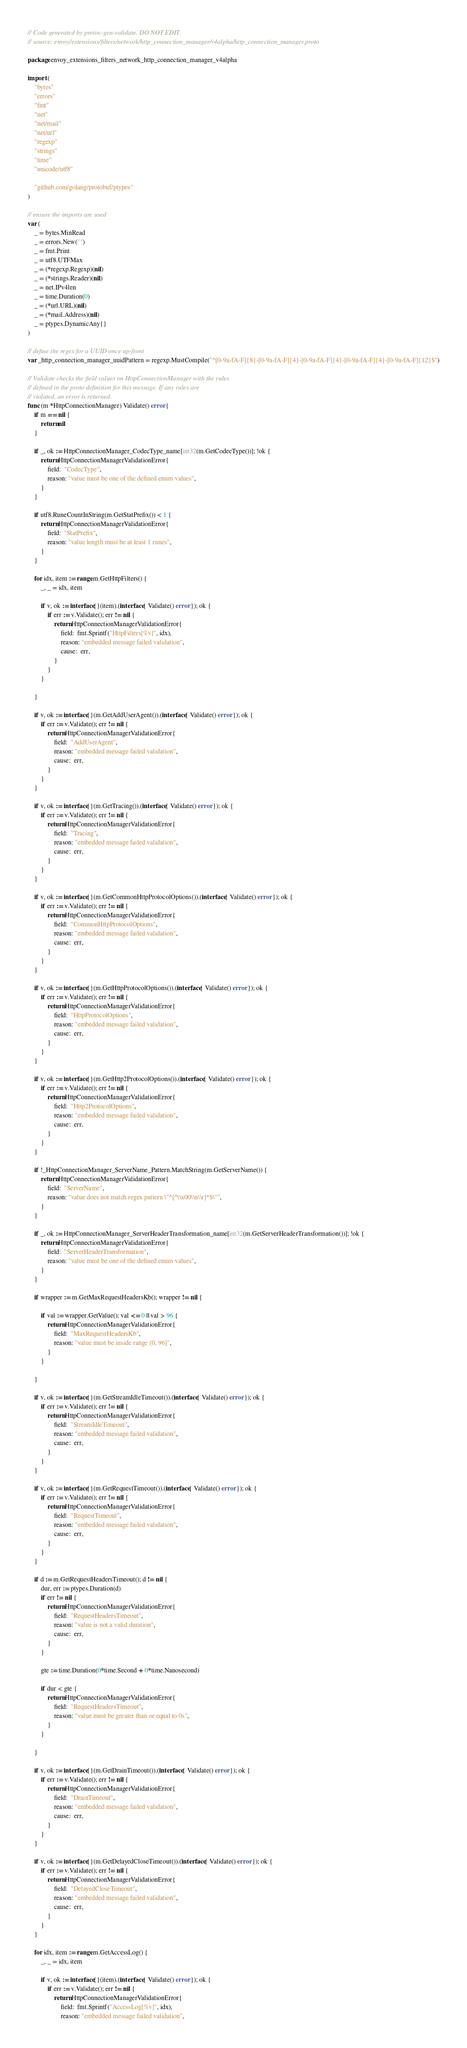<code> <loc_0><loc_0><loc_500><loc_500><_Go_>// Code generated by protoc-gen-validate. DO NOT EDIT.
// source: envoy/extensions/filters/network/http_connection_manager/v4alpha/http_connection_manager.proto

package envoy_extensions_filters_network_http_connection_manager_v4alpha

import (
	"bytes"
	"errors"
	"fmt"
	"net"
	"net/mail"
	"net/url"
	"regexp"
	"strings"
	"time"
	"unicode/utf8"

	"github.com/golang/protobuf/ptypes"
)

// ensure the imports are used
var (
	_ = bytes.MinRead
	_ = errors.New("")
	_ = fmt.Print
	_ = utf8.UTFMax
	_ = (*regexp.Regexp)(nil)
	_ = (*strings.Reader)(nil)
	_ = net.IPv4len
	_ = time.Duration(0)
	_ = (*url.URL)(nil)
	_ = (*mail.Address)(nil)
	_ = ptypes.DynamicAny{}
)

// define the regex for a UUID once up-front
var _http_connection_manager_uuidPattern = regexp.MustCompile("^[0-9a-fA-F]{8}-[0-9a-fA-F]{4}-[0-9a-fA-F]{4}-[0-9a-fA-F]{4}-[0-9a-fA-F]{12}$")

// Validate checks the field values on HttpConnectionManager with the rules
// defined in the proto definition for this message. If any rules are
// violated, an error is returned.
func (m *HttpConnectionManager) Validate() error {
	if m == nil {
		return nil
	}

	if _, ok := HttpConnectionManager_CodecType_name[int32(m.GetCodecType())]; !ok {
		return HttpConnectionManagerValidationError{
			field:  "CodecType",
			reason: "value must be one of the defined enum values",
		}
	}

	if utf8.RuneCountInString(m.GetStatPrefix()) < 1 {
		return HttpConnectionManagerValidationError{
			field:  "StatPrefix",
			reason: "value length must be at least 1 runes",
		}
	}

	for idx, item := range m.GetHttpFilters() {
		_, _ = idx, item

		if v, ok := interface{}(item).(interface{ Validate() error }); ok {
			if err := v.Validate(); err != nil {
				return HttpConnectionManagerValidationError{
					field:  fmt.Sprintf("HttpFilters[%v]", idx),
					reason: "embedded message failed validation",
					cause:  err,
				}
			}
		}

	}

	if v, ok := interface{}(m.GetAddUserAgent()).(interface{ Validate() error }); ok {
		if err := v.Validate(); err != nil {
			return HttpConnectionManagerValidationError{
				field:  "AddUserAgent",
				reason: "embedded message failed validation",
				cause:  err,
			}
		}
	}

	if v, ok := interface{}(m.GetTracing()).(interface{ Validate() error }); ok {
		if err := v.Validate(); err != nil {
			return HttpConnectionManagerValidationError{
				field:  "Tracing",
				reason: "embedded message failed validation",
				cause:  err,
			}
		}
	}

	if v, ok := interface{}(m.GetCommonHttpProtocolOptions()).(interface{ Validate() error }); ok {
		if err := v.Validate(); err != nil {
			return HttpConnectionManagerValidationError{
				field:  "CommonHttpProtocolOptions",
				reason: "embedded message failed validation",
				cause:  err,
			}
		}
	}

	if v, ok := interface{}(m.GetHttpProtocolOptions()).(interface{ Validate() error }); ok {
		if err := v.Validate(); err != nil {
			return HttpConnectionManagerValidationError{
				field:  "HttpProtocolOptions",
				reason: "embedded message failed validation",
				cause:  err,
			}
		}
	}

	if v, ok := interface{}(m.GetHttp2ProtocolOptions()).(interface{ Validate() error }); ok {
		if err := v.Validate(); err != nil {
			return HttpConnectionManagerValidationError{
				field:  "Http2ProtocolOptions",
				reason: "embedded message failed validation",
				cause:  err,
			}
		}
	}

	if !_HttpConnectionManager_ServerName_Pattern.MatchString(m.GetServerName()) {
		return HttpConnectionManagerValidationError{
			field:  "ServerName",
			reason: "value does not match regex pattern \"^[^\\x00\\n\\r]*$\"",
		}
	}

	if _, ok := HttpConnectionManager_ServerHeaderTransformation_name[int32(m.GetServerHeaderTransformation())]; !ok {
		return HttpConnectionManagerValidationError{
			field:  "ServerHeaderTransformation",
			reason: "value must be one of the defined enum values",
		}
	}

	if wrapper := m.GetMaxRequestHeadersKb(); wrapper != nil {

		if val := wrapper.GetValue(); val <= 0 || val > 96 {
			return HttpConnectionManagerValidationError{
				field:  "MaxRequestHeadersKb",
				reason: "value must be inside range (0, 96]",
			}
		}

	}

	if v, ok := interface{}(m.GetStreamIdleTimeout()).(interface{ Validate() error }); ok {
		if err := v.Validate(); err != nil {
			return HttpConnectionManagerValidationError{
				field:  "StreamIdleTimeout",
				reason: "embedded message failed validation",
				cause:  err,
			}
		}
	}

	if v, ok := interface{}(m.GetRequestTimeout()).(interface{ Validate() error }); ok {
		if err := v.Validate(); err != nil {
			return HttpConnectionManagerValidationError{
				field:  "RequestTimeout",
				reason: "embedded message failed validation",
				cause:  err,
			}
		}
	}

	if d := m.GetRequestHeadersTimeout(); d != nil {
		dur, err := ptypes.Duration(d)
		if err != nil {
			return HttpConnectionManagerValidationError{
				field:  "RequestHeadersTimeout",
				reason: "value is not a valid duration",
				cause:  err,
			}
		}

		gte := time.Duration(0*time.Second + 0*time.Nanosecond)

		if dur < gte {
			return HttpConnectionManagerValidationError{
				field:  "RequestHeadersTimeout",
				reason: "value must be greater than or equal to 0s",
			}
		}

	}

	if v, ok := interface{}(m.GetDrainTimeout()).(interface{ Validate() error }); ok {
		if err := v.Validate(); err != nil {
			return HttpConnectionManagerValidationError{
				field:  "DrainTimeout",
				reason: "embedded message failed validation",
				cause:  err,
			}
		}
	}

	if v, ok := interface{}(m.GetDelayedCloseTimeout()).(interface{ Validate() error }); ok {
		if err := v.Validate(); err != nil {
			return HttpConnectionManagerValidationError{
				field:  "DelayedCloseTimeout",
				reason: "embedded message failed validation",
				cause:  err,
			}
		}
	}

	for idx, item := range m.GetAccessLog() {
		_, _ = idx, item

		if v, ok := interface{}(item).(interface{ Validate() error }); ok {
			if err := v.Validate(); err != nil {
				return HttpConnectionManagerValidationError{
					field:  fmt.Sprintf("AccessLog[%v]", idx),
					reason: "embedded message failed validation",</code> 